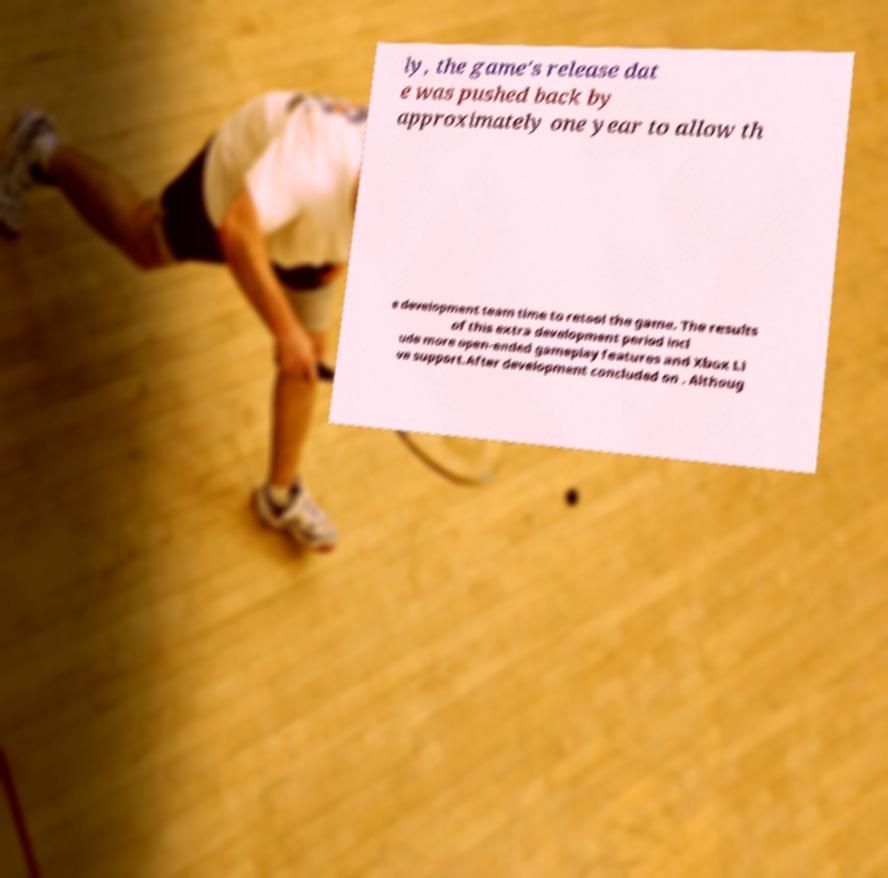There's text embedded in this image that I need extracted. Can you transcribe it verbatim? ly, the game's release dat e was pushed back by approximately one year to allow th e development team time to retool the game. The results of this extra development period incl ude more open-ended gameplay features and Xbox Li ve support.After development concluded on . Althoug 